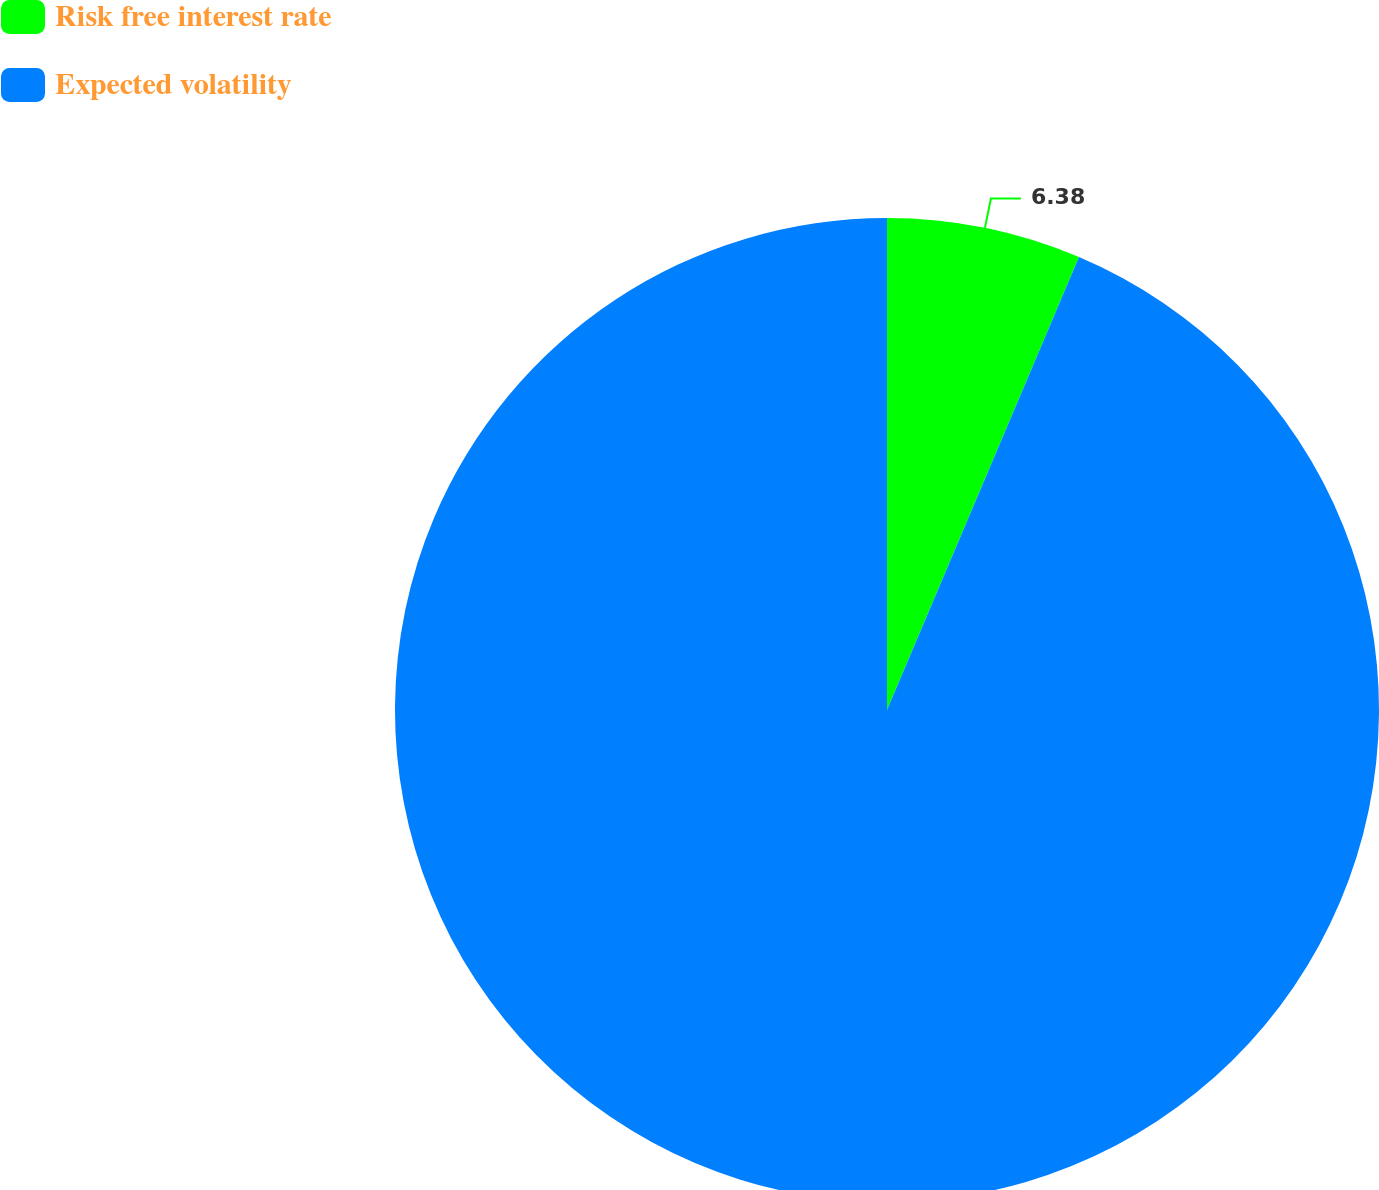<chart> <loc_0><loc_0><loc_500><loc_500><pie_chart><fcel>Risk free interest rate<fcel>Expected volatility<nl><fcel>6.38%<fcel>93.62%<nl></chart> 